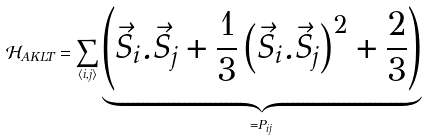Convert formula to latex. <formula><loc_0><loc_0><loc_500><loc_500>\mathcal { H } _ { A K L T } = \sum _ { \langle i , j \rangle } \underbrace { \left ( \vec { S } _ { i } . \vec { S } _ { j } + \frac { 1 } { 3 } \left ( \vec { S } _ { i } . \vec { S } _ { j } \right ) ^ { 2 } + \frac { 2 } { 3 } \right ) } _ { = P _ { i j } }</formula> 